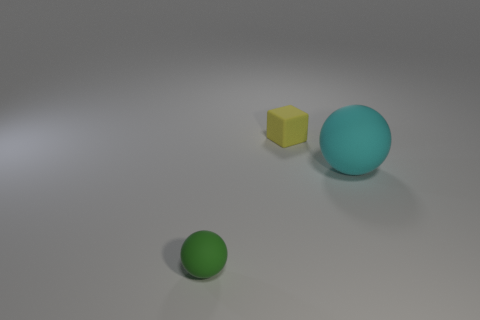Are there any other things of the same color as the tiny sphere? Upon close examination, the color of the tiny sphere appears to be unique among the objects present. It's a distinctive shade that isn't shared by the larger sphere or the cube, which both exhibit their own individual hues. 